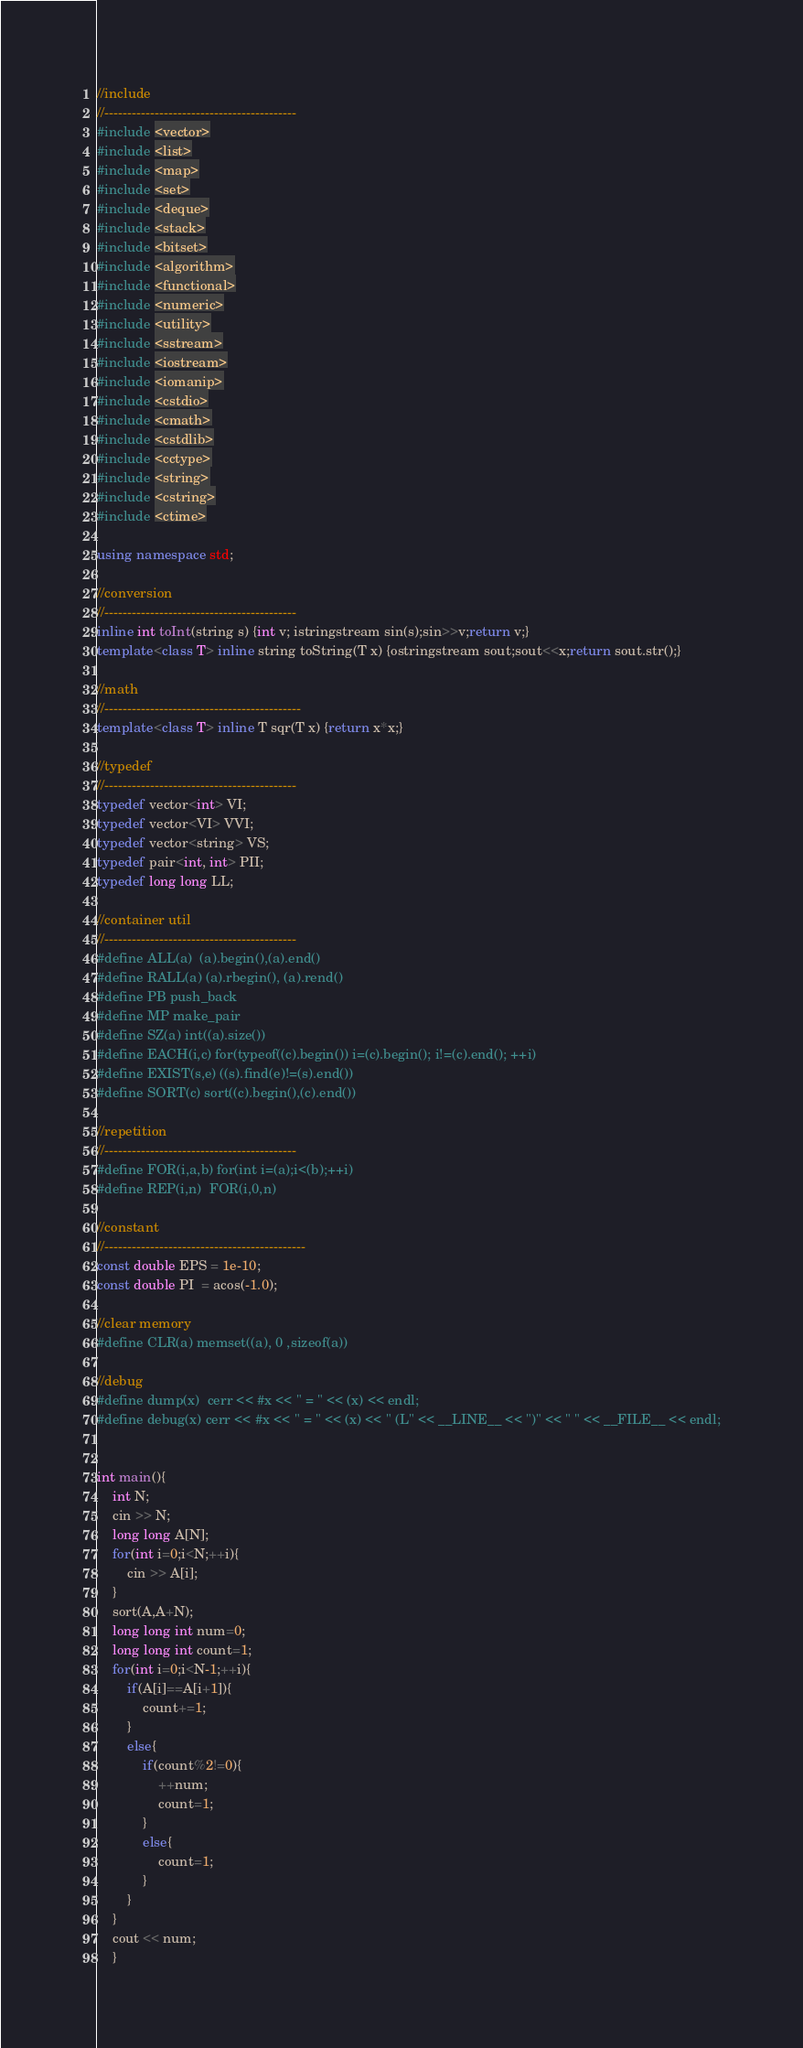Convert code to text. <code><loc_0><loc_0><loc_500><loc_500><_C++_>//include
//------------------------------------------
#include <vector>
#include <list>
#include <map>
#include <set>
#include <deque>
#include <stack>
#include <bitset>
#include <algorithm>
#include <functional>
#include <numeric>
#include <utility>
#include <sstream>
#include <iostream>
#include <iomanip>
#include <cstdio>
#include <cmath>
#include <cstdlib>
#include <cctype>
#include <string>
#include <cstring>
#include <ctime>
 
using namespace std;
 
//conversion
//------------------------------------------
inline int toInt(string s) {int v; istringstream sin(s);sin>>v;return v;}
template<class T> inline string toString(T x) {ostringstream sout;sout<<x;return sout.str();}
 
//math
//-------------------------------------------
template<class T> inline T sqr(T x) {return x*x;}
 
//typedef
//------------------------------------------
typedef vector<int> VI;
typedef vector<VI> VVI;
typedef vector<string> VS;
typedef pair<int, int> PII;
typedef long long LL;
 
//container util
//------------------------------------------
#define ALL(a)  (a).begin(),(a).end()
#define RALL(a) (a).rbegin(), (a).rend()
#define PB push_back
#define MP make_pair
#define SZ(a) int((a).size())
#define EACH(i,c) for(typeof((c).begin()) i=(c).begin(); i!=(c).end(); ++i)
#define EXIST(s,e) ((s).find(e)!=(s).end())
#define SORT(c) sort((c).begin(),(c).end())
 
//repetition
//------------------------------------------
#define FOR(i,a,b) for(int i=(a);i<(b);++i)
#define REP(i,n)  FOR(i,0,n)
 
//constant
//--------------------------------------------
const double EPS = 1e-10;
const double PI  = acos(-1.0);
 
//clear memory
#define CLR(a) memset((a), 0 ,sizeof(a))
 
//debug
#define dump(x)  cerr << #x << " = " << (x) << endl;
#define debug(x) cerr << #x << " = " << (x) << " (L" << __LINE__ << ")" << " " << __FILE__ << endl;
 
 
int main(){
    int N;
    cin >> N;
    long long A[N];
    for(int i=0;i<N;++i){
        cin >> A[i];
    }
    sort(A,A+N);
    long long int num=0;
    long long int count=1;
    for(int i=0;i<N-1;++i){
        if(A[i]==A[i+1]){
            count+=1;
        }
        else{
            if(count%2!=0){
                ++num;
                count=1;
            }
            else{
                count=1;
            }
        }
    }
    cout << num;
    }</code> 